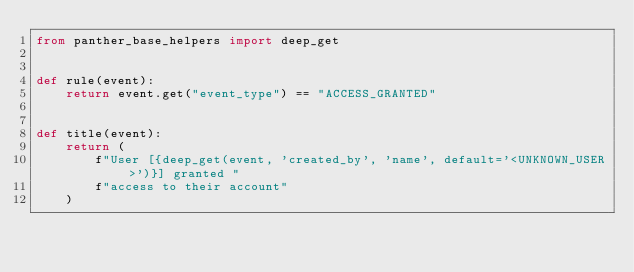Convert code to text. <code><loc_0><loc_0><loc_500><loc_500><_Python_>from panther_base_helpers import deep_get


def rule(event):
    return event.get("event_type") == "ACCESS_GRANTED"


def title(event):
    return (
        f"User [{deep_get(event, 'created_by', 'name', default='<UNKNOWN_USER>')}] granted "
        f"access to their account"
    )
</code> 